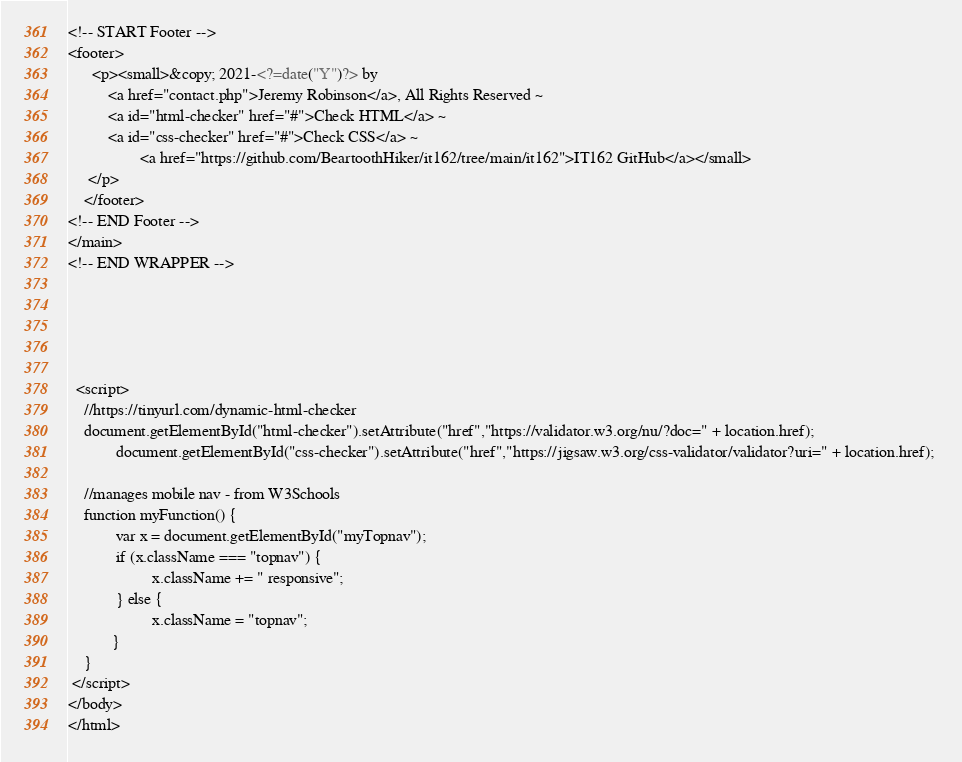Convert code to text. <code><loc_0><loc_0><loc_500><loc_500><_PHP_><!-- START Footer -->
<footer>
      <p><small>&copy; 2021-<?=date("Y")?> by 
          <a href="contact.php">Jeremy Robinson</a>, All Rights Reserved ~ 
          <a id="html-checker" href="#">Check HTML</a> ~ 
          <a id="css-checker" href="#">Check CSS</a> ~ 
				  <a href="https://github.com/BeartoothHiker/it162/tree/main/it162">IT162 GitHub</a></small>
     </p>
    </footer>
<!-- END Footer --> 
</main>
<!-- END WRAPPER -->

    



  <script>
	//https://tinyurl.com/dynamic-html-checker
	document.getElementById("html-checker").setAttribute("href","https://validator.w3.org/nu/?doc=" + location.href);
            document.getElementById("css-checker").setAttribute("href","https://jigsaw.w3.org/css-validator/validator?uri=" + location.href); 

	//manages mobile nav - from W3Schools
	function myFunction() {
    	    var x = document.getElementById("myTopnav");
    	    if (x.className === "topnav") {
        	         x.className += " responsive";
    	    } else {
        	         x.className = "topnav";
    	   }
	}   
 </script>
</body>
</html>
</code> 